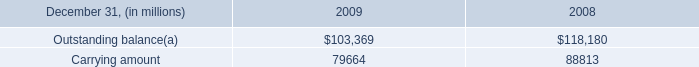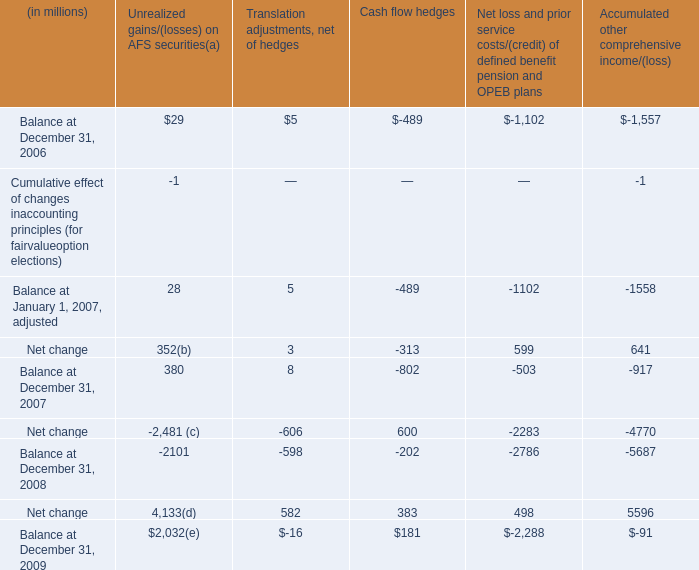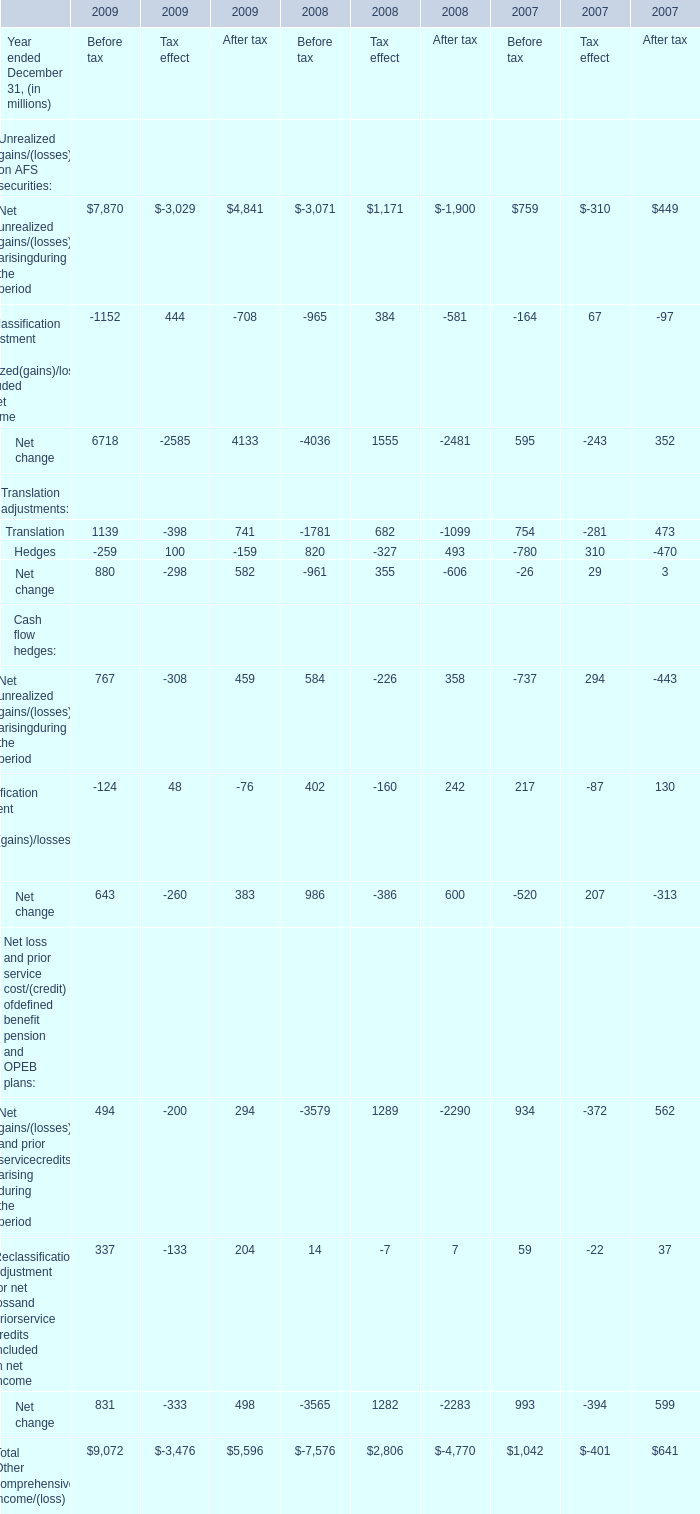What's the current increasing rate of Net unrealized gains/(losses) arisingduring the period for Before tax? 
Computations: ((767 - 584) / 584)
Answer: 0.31336. 